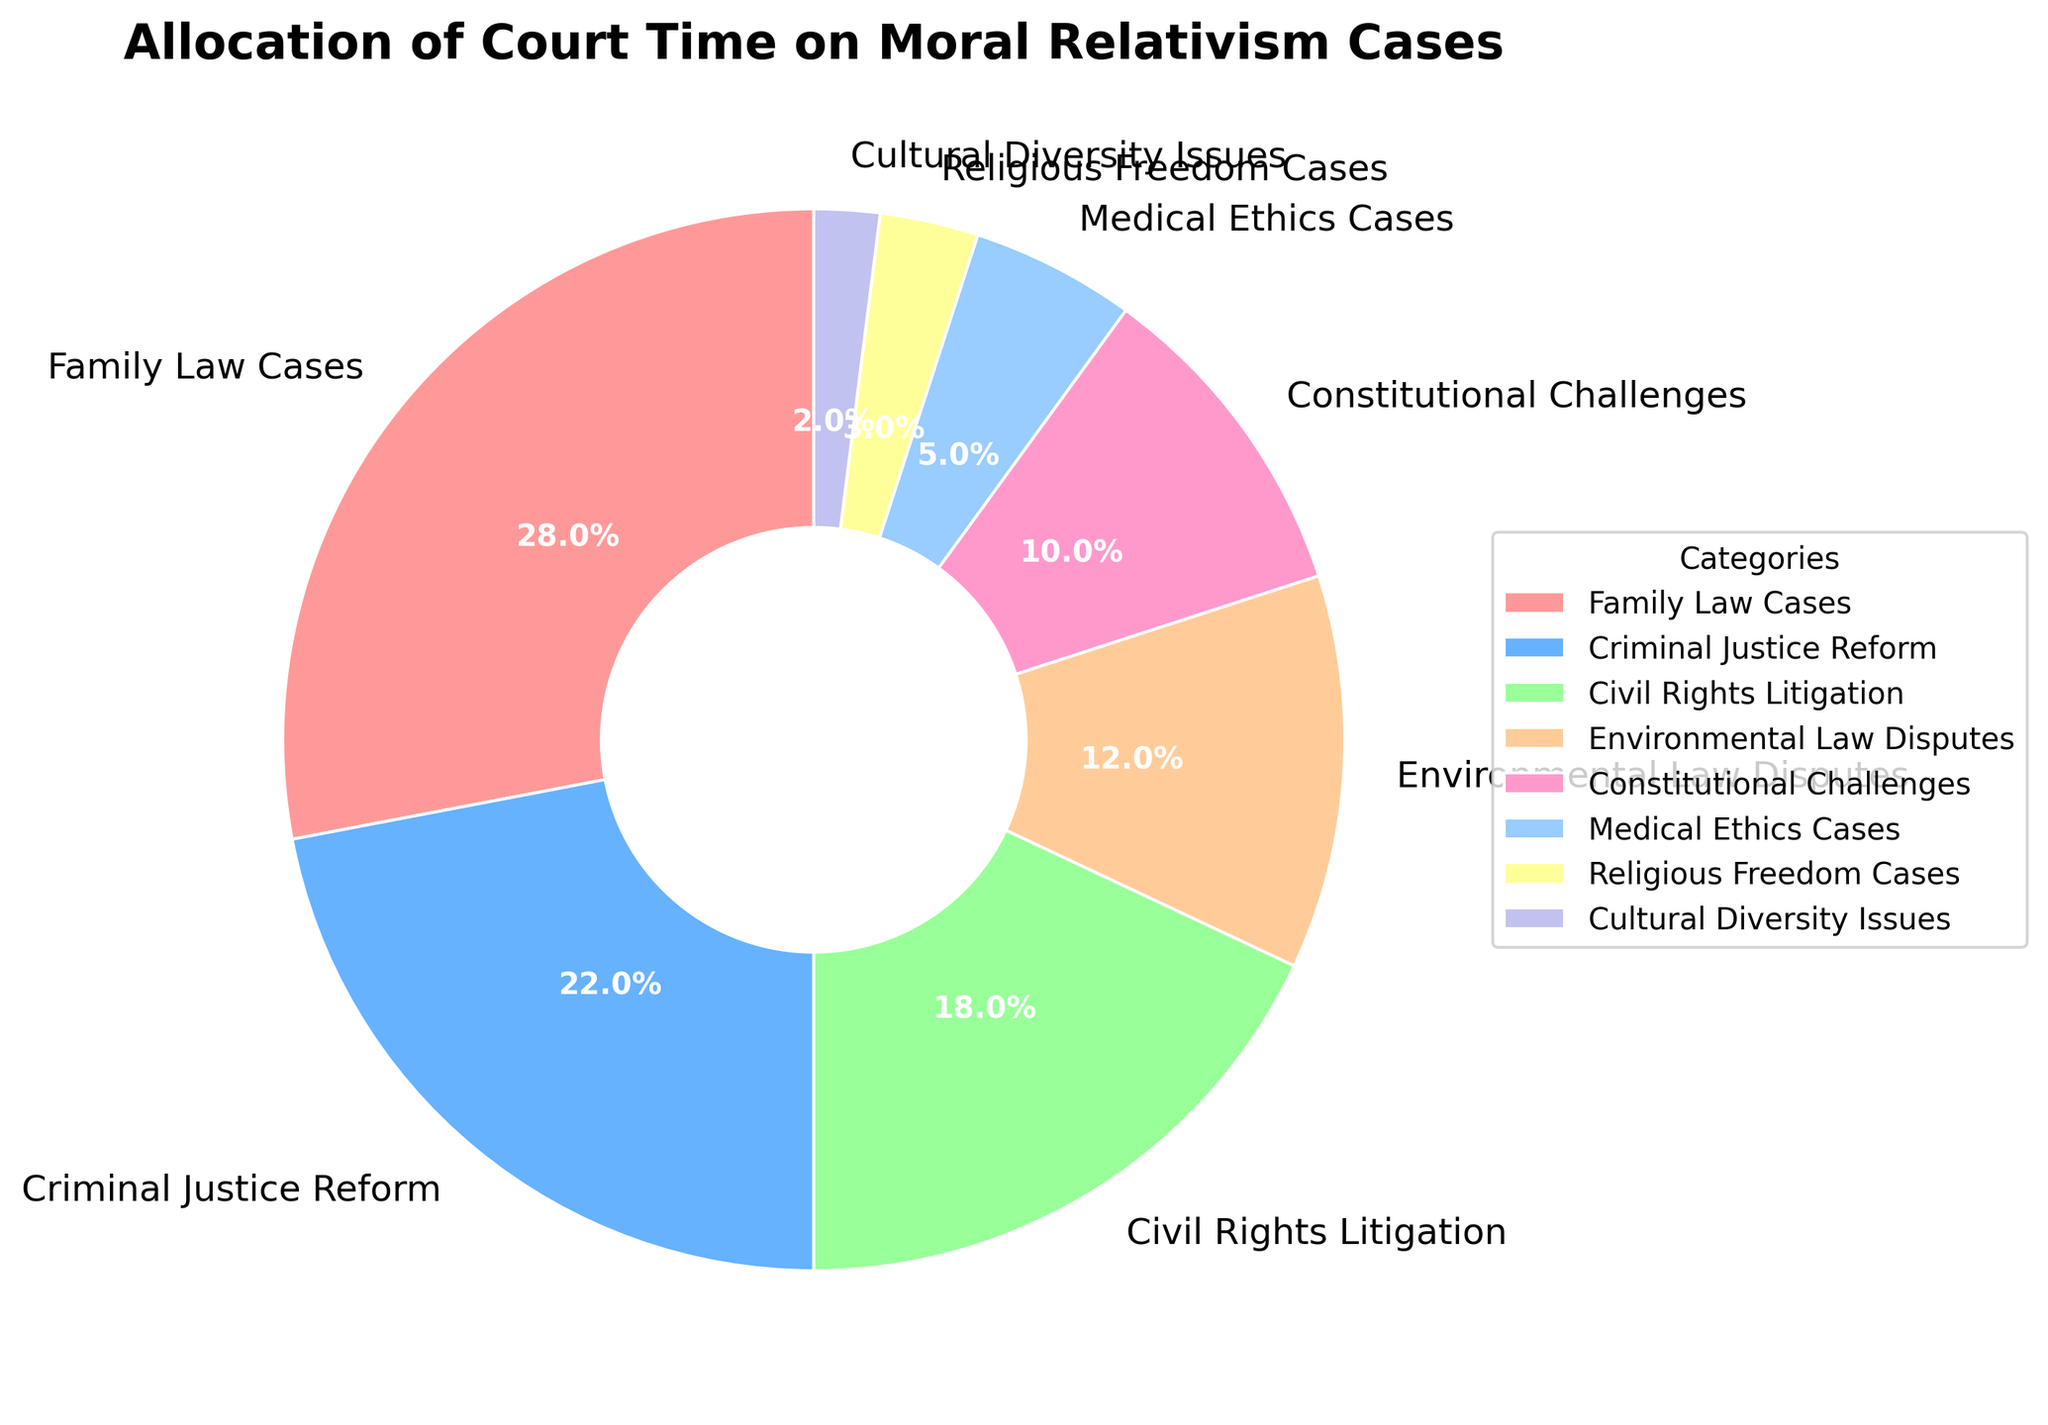What's the category with the highest allocation of court time? The figure shows multiple slices labeled with categories. The largest slice with the corresponding label has the highest percentage.
Answer: Family Law Cases How much more time is spent on Family Law Cases compared to Medical Ethics Cases? Family Law Cases account for 28% of the court time, and Medical Ethics Cases account for 5%. By subtracting the two percentages (28% - 5%), we get the difference.
Answer: 23% Which categories have a combined allocation of more than 40% of court time? Summing the percentages of each category will help determine which combinations exceed 40%. Examining the labels and performing the addition, we find that Family Law Cases (28%) and Criminal Justice Reform (22%) together combine to 50%.
Answer: Family Law Cases and Criminal Justice Reform What is the least allocated category? The smallest slice in the pie chart, according to the label, indicates the category with the lowest percentage.
Answer: Cultural Diversity Issues How does the time allocation for Civil Rights Litigation compare to Environmental Law Disputes? The chart shows Civil Rights Litigation at 18% and Environmental Law Disputes at 12%. By direct comparison, Civil Rights Litigation has a higher allocation.
Answer: Civil Rights Litigation has a higher allocation What is the sum of the allocation percentages for Constitutional Challenges and Medical Ethics Cases? The percentages for Constitutional Challenges (10%) and Medical Ethics Cases (5%) are provided. Adding these values gives the total allocation.
Answer: 15% If Religious Freedom Cases and Cultural Diversity Issues are combined into a single category, what percentage of court time would that represent? Religious Freedom Cases account for 3% and Cultural Diversity Issues account for 2%. Adding these percentages (3% + 2%) gives the combined total.
Answer: 5% Which slice is visually represented by a purple color? The chart uses distinct colors for each category. Identifying the purple slice based on its label helps answer this question.
Answer: Empty or no purple slice (based on the description in the question, only certain colors are given which do not include purple) Does the allocation for Criminal Justice Reform exceed that of all other categories except Family Law Cases? By comparing percentages, Criminal Justice Reform has 22%, which is higher than all other categories except for Family Law Cases at 28%.
Answer: Yes How much more court time is spent on Environmental Law Disputes compared to Religious Freedom Cases? Environmental Law Disputes account for 12%, while Religious Freedom Cases account for 3%. Subtracting these values (12% - 3%) gives the difference.
Answer: 9% 